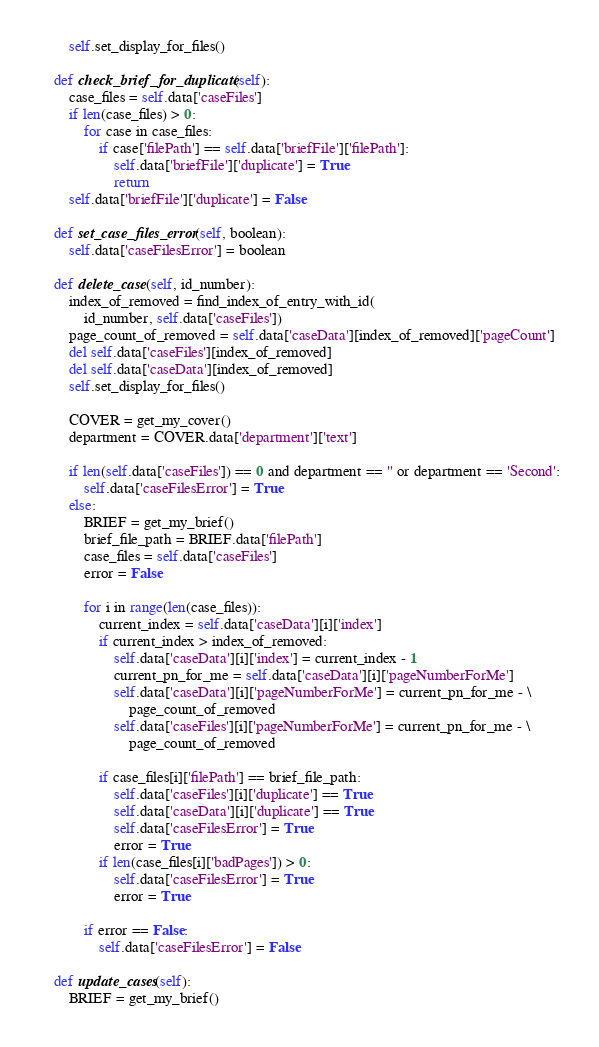<code> <loc_0><loc_0><loc_500><loc_500><_Python_>        self.set_display_for_files()

    def check_brief_for_duplicate(self):
        case_files = self.data['caseFiles']
        if len(case_files) > 0:
            for case in case_files:
                if case['filePath'] == self.data['briefFile']['filePath']:
                    self.data['briefFile']['duplicate'] = True
                    return
        self.data['briefFile']['duplicate'] = False

    def set_case_files_error(self, boolean):
        self.data['caseFilesError'] = boolean

    def delete_case(self, id_number):
        index_of_removed = find_index_of_entry_with_id(
            id_number, self.data['caseFiles'])
        page_count_of_removed = self.data['caseData'][index_of_removed]['pageCount']
        del self.data['caseFiles'][index_of_removed]
        del self.data['caseData'][index_of_removed]
        self.set_display_for_files()

        COVER = get_my_cover()
        department = COVER.data['department']['text']

        if len(self.data['caseFiles']) == 0 and department == '' or department == 'Second':
            self.data['caseFilesError'] = True
        else:
            BRIEF = get_my_brief()
            brief_file_path = BRIEF.data['filePath']
            case_files = self.data['caseFiles']
            error = False

            for i in range(len(case_files)):
                current_index = self.data['caseData'][i]['index']
                if current_index > index_of_removed:
                    self.data['caseData'][i]['index'] = current_index - 1
                    current_pn_for_me = self.data['caseData'][i]['pageNumberForMe']
                    self.data['caseData'][i]['pageNumberForMe'] = current_pn_for_me - \
                        page_count_of_removed
                    self.data['caseFiles'][i]['pageNumberForMe'] = current_pn_for_me - \
                        page_count_of_removed

                if case_files[i]['filePath'] == brief_file_path:
                    self.data['caseFiles'][i]['duplicate'] == True
                    self.data['caseData'][i]['duplicate'] == True
                    self.data['caseFilesError'] = True
                    error = True
                if len(case_files[i]['badPages']) > 0:
                    self.data['caseFilesError'] = True
                    error = True

            if error == False:
                self.data['caseFilesError'] = False

    def update_cases(self):
        BRIEF = get_my_brief()</code> 